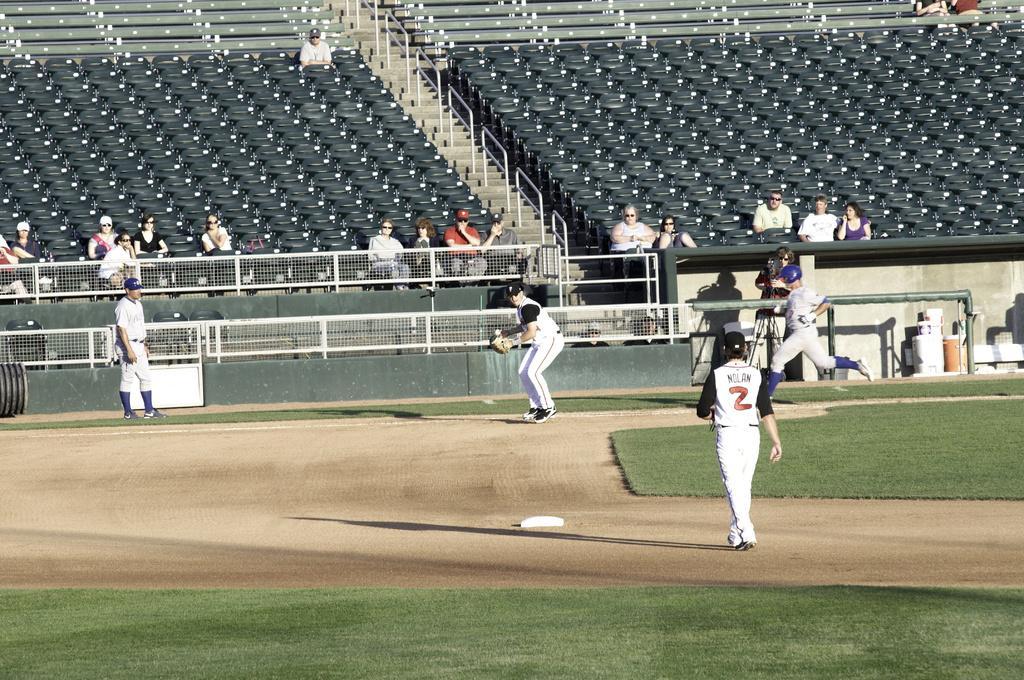Could you give a brief overview of what you see in this image? This is a picture taken in a baseball ground. In the foreground of the picture there is grass and soil. In the center of the picture there are players, railing. At the top there are chairs and benches, there are people sitting in chairs and benches. It is sunny. 